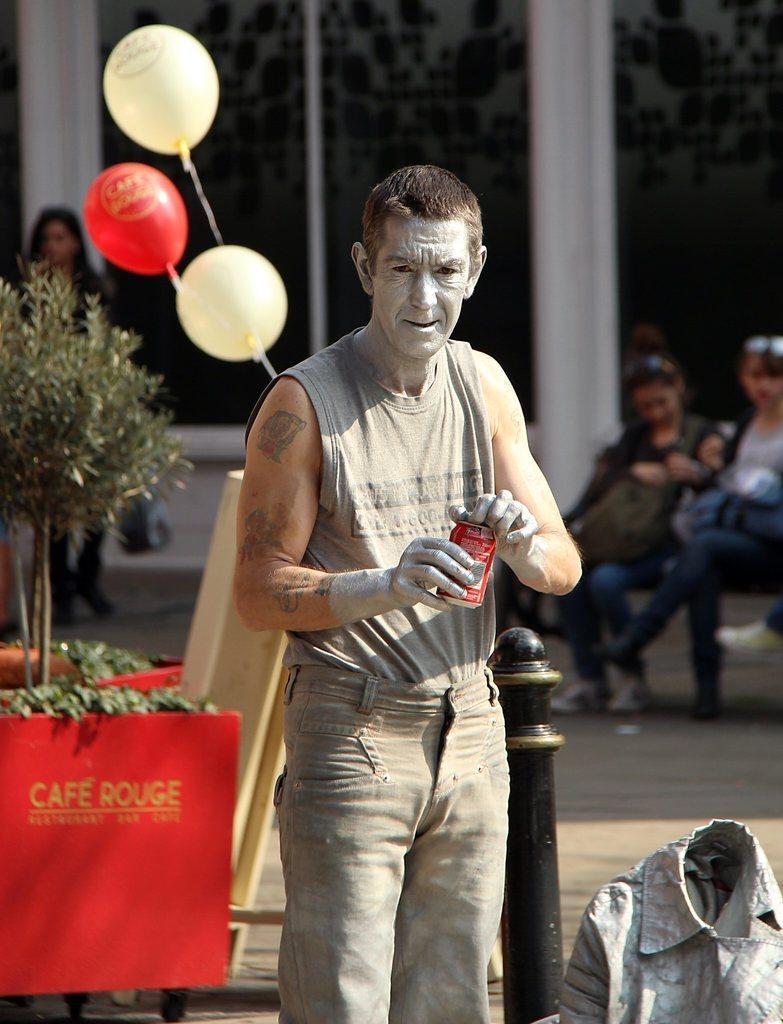Describe this image in one or two sentences. In the center of the image there is a man holding a tin. In the background we can see balloons, plants, persons and building. 